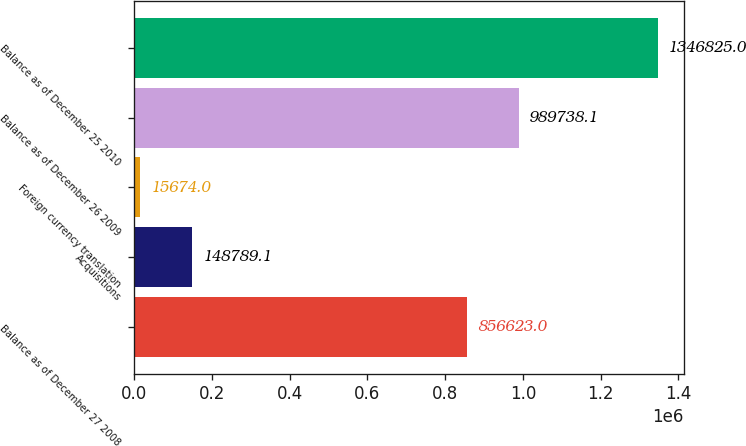<chart> <loc_0><loc_0><loc_500><loc_500><bar_chart><fcel>Balance as of December 27 2008<fcel>Acquisitions<fcel>Foreign currency translation<fcel>Balance as of December 26 2009<fcel>Balance as of December 25 2010<nl><fcel>856623<fcel>148789<fcel>15674<fcel>989738<fcel>1.34682e+06<nl></chart> 